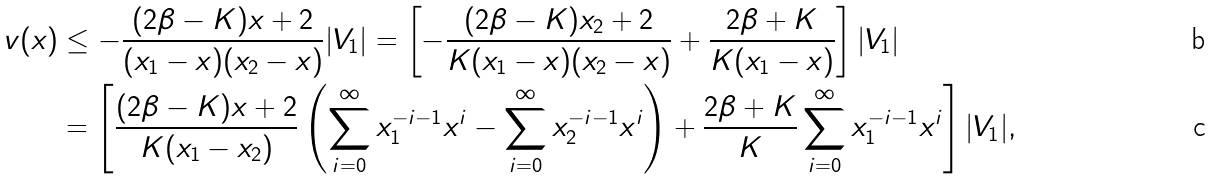<formula> <loc_0><loc_0><loc_500><loc_500>v ( x ) & \leq - \frac { ( 2 \beta - K ) x + 2 } { ( x _ { 1 } - x ) ( x _ { 2 } - x ) } | V _ { 1 } | = \left [ - \frac { ( 2 \beta - K ) x _ { 2 } + 2 } { K ( x _ { 1 } - x ) ( x _ { 2 } - x ) } + \frac { 2 \beta + K } { K ( x _ { 1 } - x ) } \right ] | V _ { 1 } | \\ & = \left [ \frac { ( 2 \beta - K ) x + 2 } { K ( x _ { 1 } - x _ { 2 } ) } \left ( \sum _ { i = 0 } ^ { \infty } x _ { 1 } ^ { - i - 1 } x ^ { i } - \sum _ { i = 0 } ^ { \infty } x _ { 2 } ^ { - i - 1 } x ^ { i } \right ) + \frac { 2 \beta + K } { K } \sum _ { i = 0 } ^ { \infty } x _ { 1 } ^ { - i - 1 } x ^ { i } \right ] | V _ { 1 } | ,</formula> 